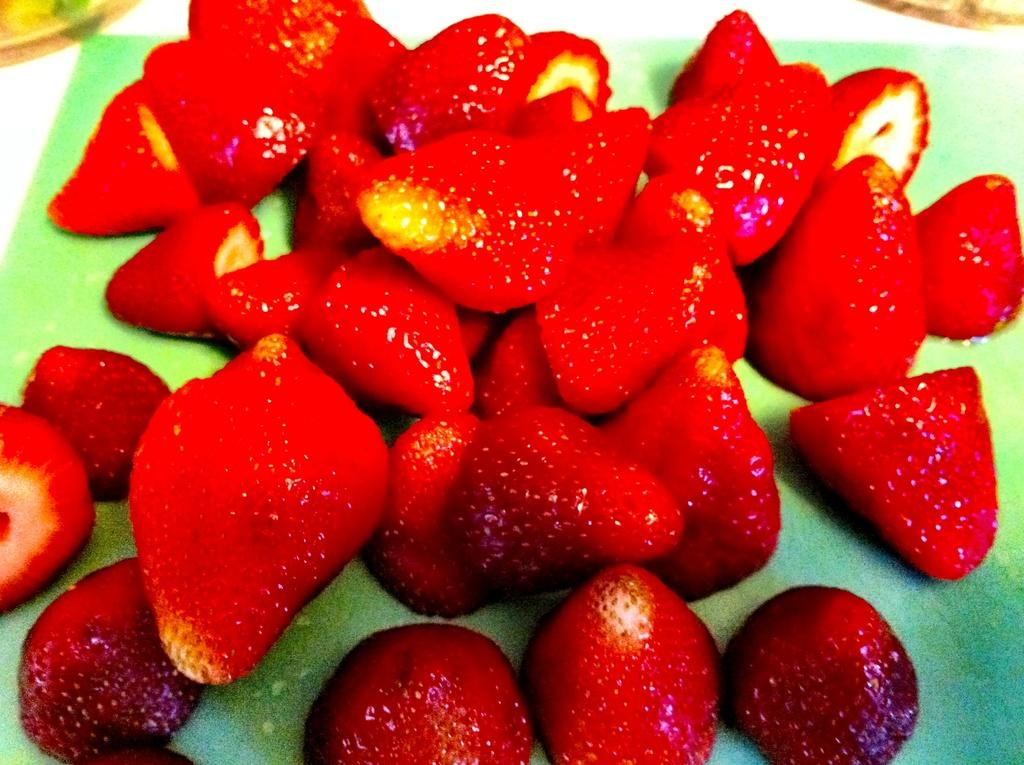What type of fruit is present in the image? There are strawberries in the image. What color are the strawberries? The strawberries are red in color. What type of jewel is located in the stomach of the strawberry in the image? There is no jewel present in the image, and strawberries do not have stomachs. 